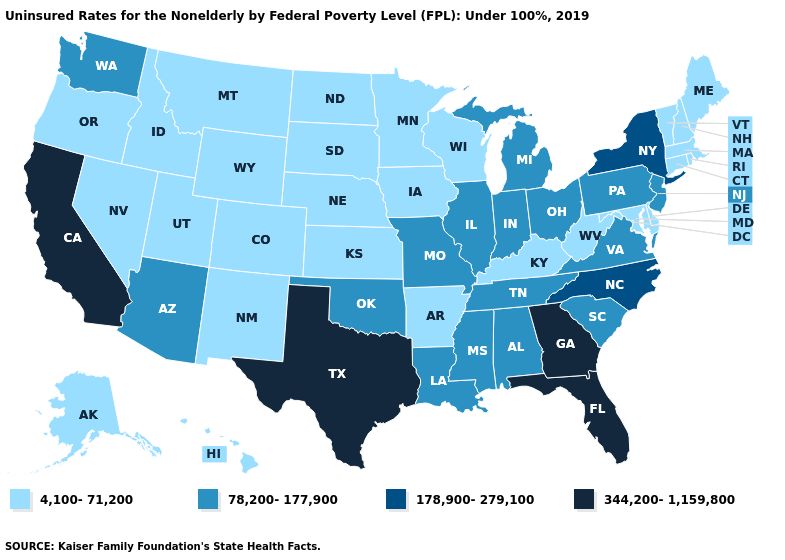Which states have the lowest value in the South?
Quick response, please. Arkansas, Delaware, Kentucky, Maryland, West Virginia. What is the value of Washington?
Give a very brief answer. 78,200-177,900. Which states have the lowest value in the USA?
Concise answer only. Alaska, Arkansas, Colorado, Connecticut, Delaware, Hawaii, Idaho, Iowa, Kansas, Kentucky, Maine, Maryland, Massachusetts, Minnesota, Montana, Nebraska, Nevada, New Hampshire, New Mexico, North Dakota, Oregon, Rhode Island, South Dakota, Utah, Vermont, West Virginia, Wisconsin, Wyoming. Does South Carolina have the lowest value in the South?
Answer briefly. No. What is the value of Nebraska?
Quick response, please. 4,100-71,200. What is the value of North Dakota?
Write a very short answer. 4,100-71,200. What is the highest value in states that border Georgia?
Quick response, please. 344,200-1,159,800. Name the states that have a value in the range 78,200-177,900?
Write a very short answer. Alabama, Arizona, Illinois, Indiana, Louisiana, Michigan, Mississippi, Missouri, New Jersey, Ohio, Oklahoma, Pennsylvania, South Carolina, Tennessee, Virginia, Washington. Which states have the highest value in the USA?
Quick response, please. California, Florida, Georgia, Texas. What is the highest value in the USA?
Concise answer only. 344,200-1,159,800. What is the value of Kentucky?
Keep it brief. 4,100-71,200. How many symbols are there in the legend?
Answer briefly. 4. Does California have the lowest value in the USA?
Concise answer only. No. Is the legend a continuous bar?
Give a very brief answer. No. 